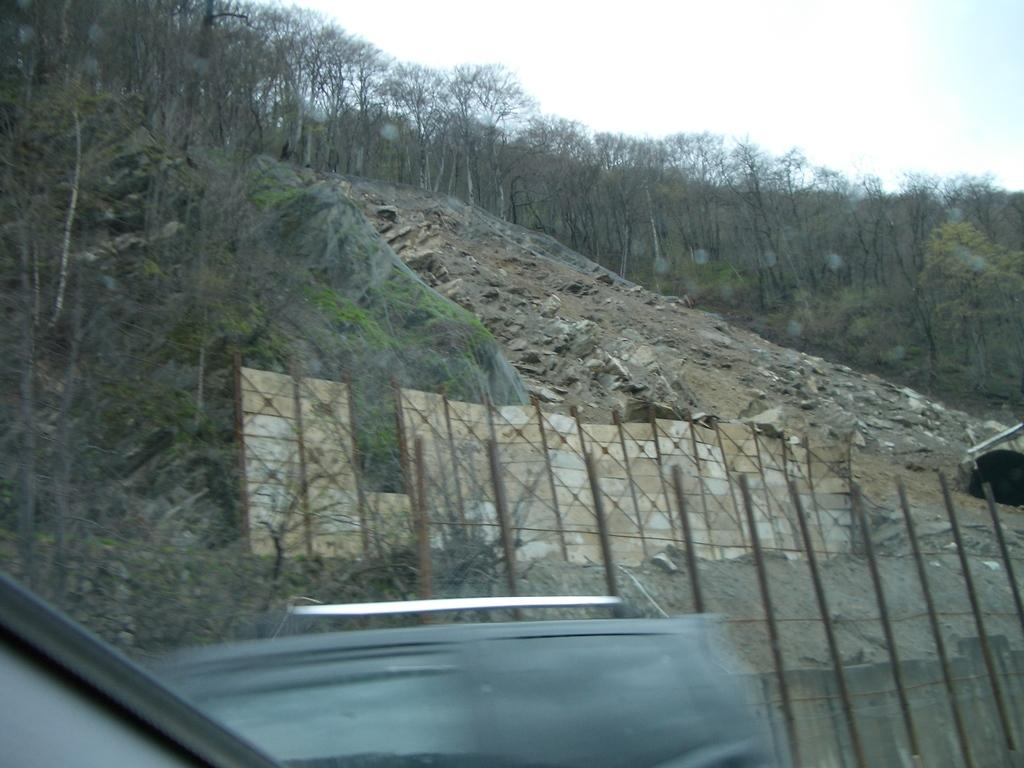What type of natural elements can be seen in the image? There are trees in the image. Where are the trees located? The trees are on hills. What type of furniture can be seen in the image? There is no furniture present in the image; it features trees on hills. How many bikes are visible in the image? There are no bikes present in the image. 